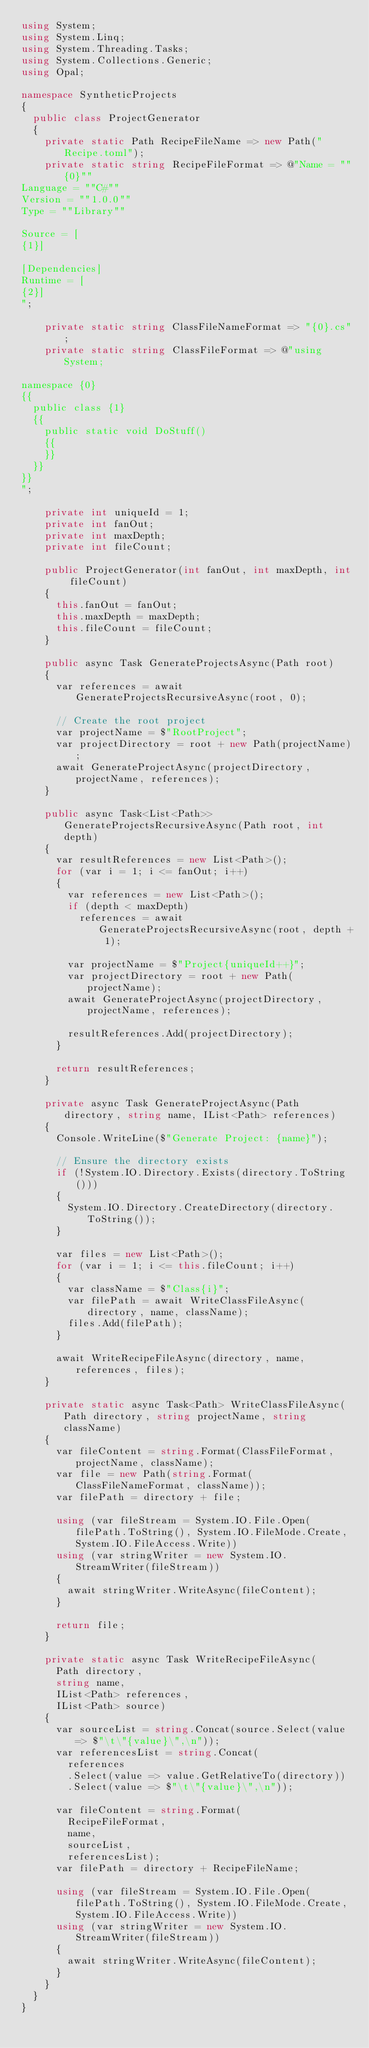<code> <loc_0><loc_0><loc_500><loc_500><_C#_>using System;
using System.Linq;
using System.Threading.Tasks;
using System.Collections.Generic;
using Opal;

namespace SyntheticProjects
{
	public class ProjectGenerator
	{
		private static Path RecipeFileName => new Path("Recipe.toml");
		private static string RecipeFileFormat => @"Name = ""{0}""
Language = ""C#""
Version = ""1.0.0""
Type = ""Library""

Source = [
{1}]

[Dependencies]
Runtime = [
{2}]
";

		private static string ClassFileNameFormat => "{0}.cs";
		private static string ClassFileFormat => @"using System;

namespace {0}
{{
	public class {1}
	{{
		public static void DoStuff()
		{{
		}}
	}}
}}
";

		private int uniqueId = 1;
		private int fanOut;
		private int maxDepth;
		private int fileCount;

		public ProjectGenerator(int fanOut, int maxDepth, int fileCount)
		{
			this.fanOut = fanOut;
			this.maxDepth = maxDepth;
			this.fileCount = fileCount;
		}

		public async Task GenerateProjectsAsync(Path root)
		{
			var references = await GenerateProjectsRecursiveAsync(root, 0);

			// Create the root project
			var projectName = $"RootProject";
			var projectDirectory = root + new Path(projectName);
			await GenerateProjectAsync(projectDirectory, projectName, references);
		}

		public async Task<List<Path>> GenerateProjectsRecursiveAsync(Path root, int depth)
		{
			var resultReferences = new List<Path>();
			for (var i = 1; i <= fanOut; i++)
			{
				var references = new List<Path>();
				if (depth < maxDepth)
					references = await GenerateProjectsRecursiveAsync(root, depth + 1);

				var projectName = $"Project{uniqueId++}";
				var projectDirectory = root + new Path(projectName);
				await GenerateProjectAsync(projectDirectory, projectName, references);

				resultReferences.Add(projectDirectory);
			}

			return resultReferences;
		}

		private async Task GenerateProjectAsync(Path directory, string name, IList<Path> references)
		{
			Console.WriteLine($"Generate Project: {name}");

			// Ensure the directory exists
			if (!System.IO.Directory.Exists(directory.ToString()))
			{
				System.IO.Directory.CreateDirectory(directory.ToString());
			}

			var files = new List<Path>();
			for (var i = 1; i <= this.fileCount; i++)
			{
				var className = $"Class{i}";
				var filePath = await WriteClassFileAsync(directory, name, className);
				files.Add(filePath);
			}

			await WriteRecipeFileAsync(directory, name, references, files);
		}

		private static async Task<Path> WriteClassFileAsync(Path directory, string projectName, string className)
		{
			var fileContent = string.Format(ClassFileFormat, projectName, className);
			var file = new Path(string.Format(ClassFileNameFormat, className));
			var filePath = directory + file;

			using (var fileStream = System.IO.File.Open(filePath.ToString(), System.IO.FileMode.Create, System.IO.FileAccess.Write))
			using (var stringWriter = new System.IO.StreamWriter(fileStream))
			{
				await stringWriter.WriteAsync(fileContent);
			}

			return file;
		}

		private static async Task WriteRecipeFileAsync(
			Path directory,
			string name,
			IList<Path> references,
			IList<Path> source)
		{
			var sourceList = string.Concat(source.Select(value => $"\t\"{value}\",\n"));
			var referencesList = string.Concat(
				references
				.Select(value => value.GetRelativeTo(directory))
				.Select(value => $"\t\"{value}\",\n"));

			var fileContent = string.Format(
				RecipeFileFormat,
				name,
				sourceList,
				referencesList);
			var filePath = directory + RecipeFileName;

			using (var fileStream = System.IO.File.Open(filePath.ToString(), System.IO.FileMode.Create, System.IO.FileAccess.Write))
			using (var stringWriter = new System.IO.StreamWriter(fileStream))
			{
				await stringWriter.WriteAsync(fileContent);
			}
		}
	}
}
</code> 